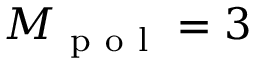<formula> <loc_0><loc_0><loc_500><loc_500>M _ { p o l } = 3</formula> 